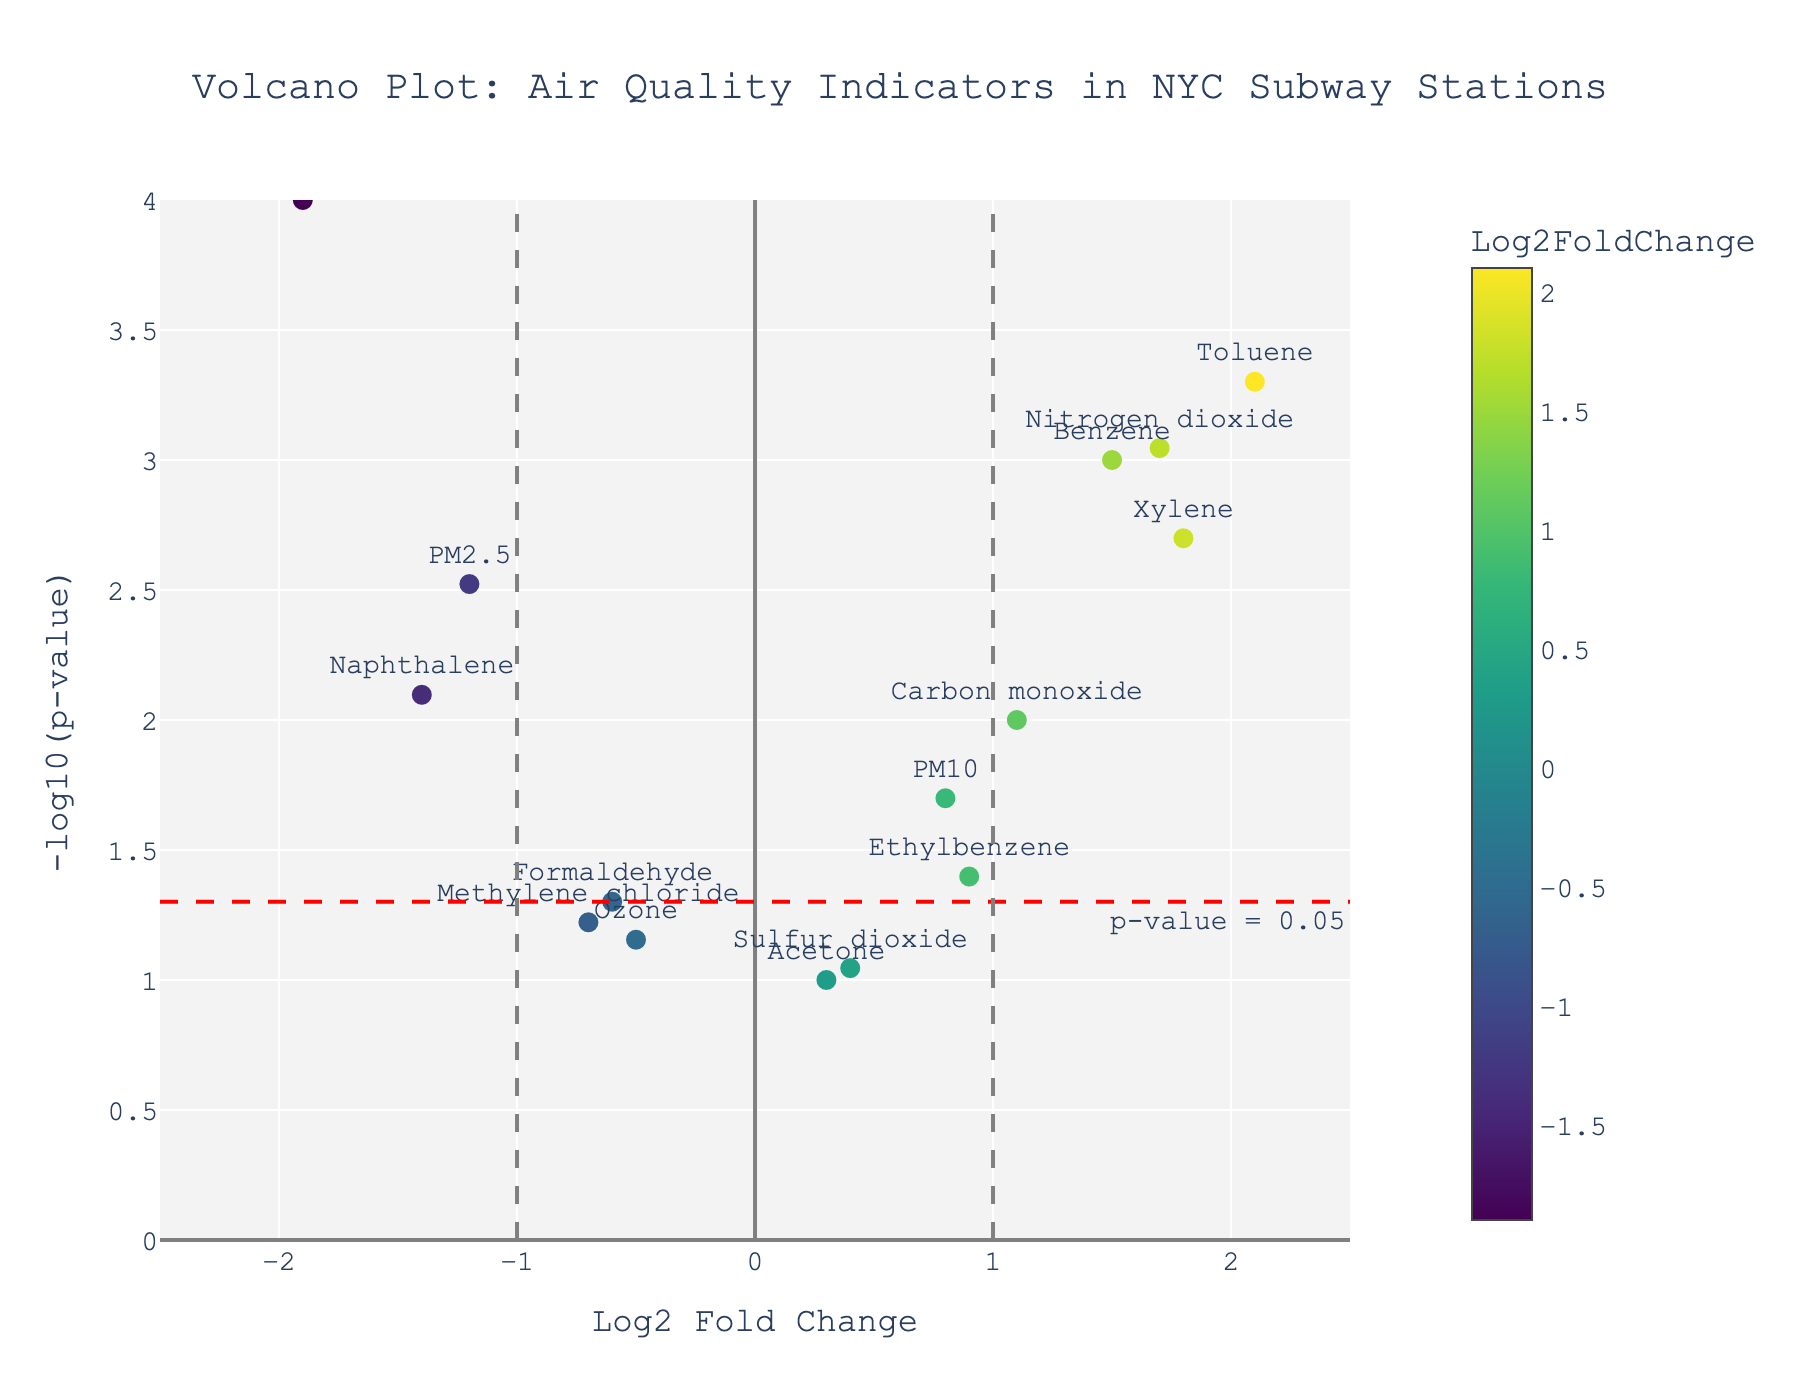How many compounds have a significant P-value? Look for the horizontal red dashed line at y = -log10(0.05). Count the number of points above this line as they represent compounds with significant P-values (P < 0.05). There are 7 such compounds (PM2.5, Benzene, Toluene, Xylene, Carbon monoxide, Nitrogen dioxide, Acrolein).
Answer: 7 Which compound has the highest Log2 Fold Change? Compare all the Log2 Fold Change values on the x-axis and identify the one that is farthest to the right. Toluene has the highest Log2 Fold Change of 2.1.
Answer: Toluene What is the P-value threshold used in this plot? Identify the horizontal red dashed line representing the P-value threshold. The annotation on this line shows that it represents a P-value of 0.05.
Answer: 0.05 How many compounds have a Log2 Fold Change greater than 1? Count the number of data points to the right of the vertical grey dashed line at x = 1. There are 4 such compounds (Toluene, Xylene, Carbon monoxide, Nitrogen dioxide).
Answer: 4 Which compound has the lowest -log10(P-value)? Look for the point with the lowest y-value. Acetone has the lowest -log10(P-value), with a P-value of 0.1.
Answer: Acetone Compare PM2.5 and PM10 in terms of Log2 Fold Change and -log10(P-value). PM2.5 has a Log2 Fold Change of -1.2 and a -log10(P-value) of 2.52. PM10 has a Log2 Fold Change of 0.8 and a -log10(P-value) of 1.70. PM2.5 has a lower Log2 Fold Change and a higher -log10(P-value) compared to PM10.
Answer: PM2.5 has lower Log2 Fold Change, higher -log10(P-value) Which compounds are considered both significant and upregulated (positive Log2 Fold Change and P-value < 0.05)? Identify compounds with Log2 Fold Change > 0 and y-values above the red dashed line (-log10(0.05)). The compounds are Benzene, Toluene, Xylene, Carbon monoxide, and Nitrogen dioxide.
Answer: Benzene, Toluene, Xylene, Carbon monoxide, Nitrogen dioxide How many compounds are downregulated (negative Log2 Fold Change) but not significant? Look for compounds to the left of the vertical grey line at x = -1 with y-values below the red dashed line. There are 2 compounds: Formaldehyde and Ozone.
Answer: 2 